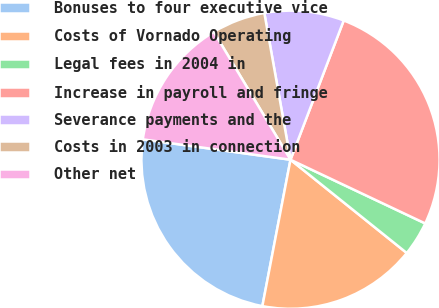<chart> <loc_0><loc_0><loc_500><loc_500><pie_chart><fcel>Bonuses to four executive vice<fcel>Costs of Vornado Operating<fcel>Legal fees in 2004 in<fcel>Increase in payroll and fringe<fcel>Severance payments and the<fcel>Costs in 2003 in connection<fcel>Other net<nl><fcel>24.16%<fcel>17.26%<fcel>3.73%<fcel>26.22%<fcel>8.62%<fcel>5.79%<fcel>14.22%<nl></chart> 